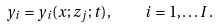Convert formula to latex. <formula><loc_0><loc_0><loc_500><loc_500>y _ { i } = y _ { i } ( x ; z _ { j } ; t ) \, , \quad i = 1 , \dots I \, .</formula> 